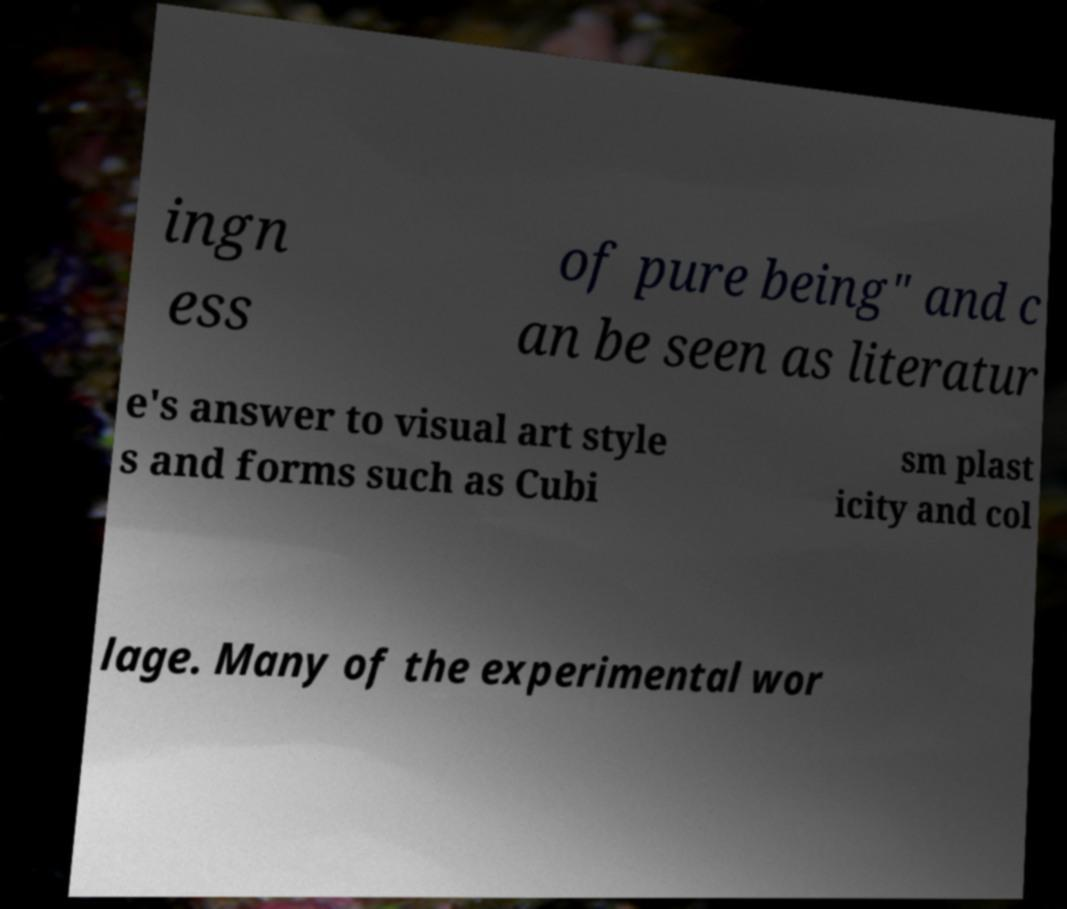For documentation purposes, I need the text within this image transcribed. Could you provide that? ingn ess of pure being" and c an be seen as literatur e's answer to visual art style s and forms such as Cubi sm plast icity and col lage. Many of the experimental wor 